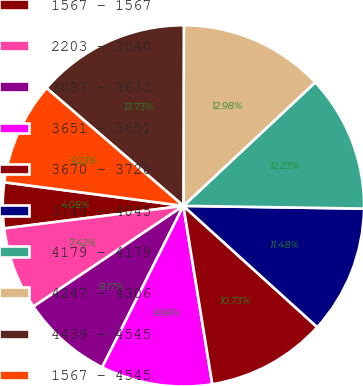<chart> <loc_0><loc_0><loc_500><loc_500><pie_chart><fcel>1567 - 1567<fcel>2203 - 3040<fcel>3087 - 3633<fcel>3651 - 3651<fcel>3670 - 3720<fcel>3749 - 4045<fcel>4179 - 4179<fcel>4247 - 4306<fcel>4439 - 4545<fcel>1567 - 4545<nl><fcel>4.08%<fcel>7.42%<fcel>8.17%<fcel>9.98%<fcel>10.73%<fcel>11.48%<fcel>12.23%<fcel>12.98%<fcel>13.73%<fcel>9.23%<nl></chart> 